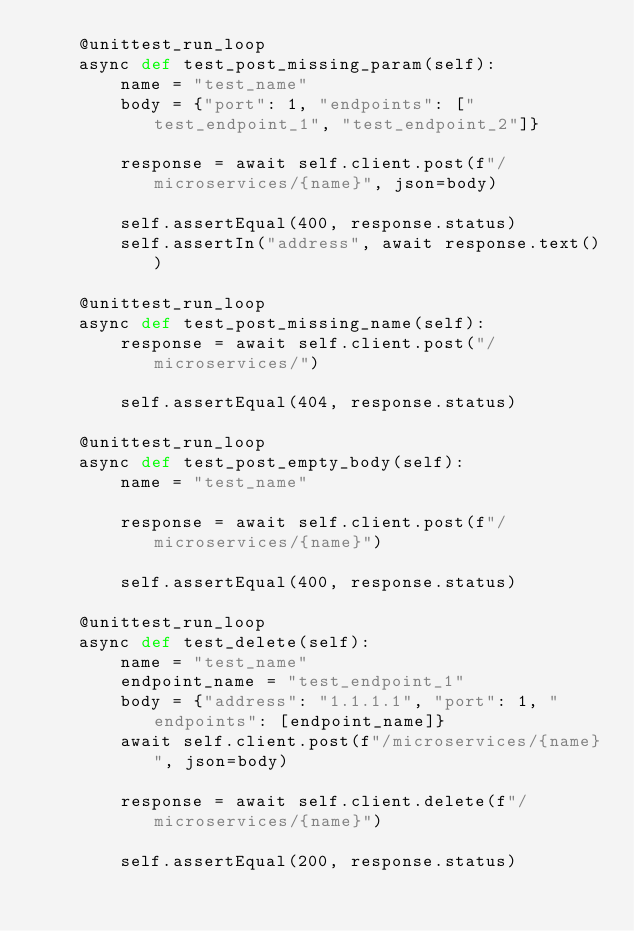<code> <loc_0><loc_0><loc_500><loc_500><_Python_>    @unittest_run_loop
    async def test_post_missing_param(self):
        name = "test_name"
        body = {"port": 1, "endpoints": ["test_endpoint_1", "test_endpoint_2"]}

        response = await self.client.post(f"/microservices/{name}", json=body)

        self.assertEqual(400, response.status)
        self.assertIn("address", await response.text())

    @unittest_run_loop
    async def test_post_missing_name(self):
        response = await self.client.post("/microservices/")

        self.assertEqual(404, response.status)

    @unittest_run_loop
    async def test_post_empty_body(self):
        name = "test_name"

        response = await self.client.post(f"/microservices/{name}")

        self.assertEqual(400, response.status)

    @unittest_run_loop
    async def test_delete(self):
        name = "test_name"
        endpoint_name = "test_endpoint_1"
        body = {"address": "1.1.1.1", "port": 1, "endpoints": [endpoint_name]}
        await self.client.post(f"/microservices/{name}", json=body)

        response = await self.client.delete(f"/microservices/{name}")

        self.assertEqual(200, response.status)
</code> 